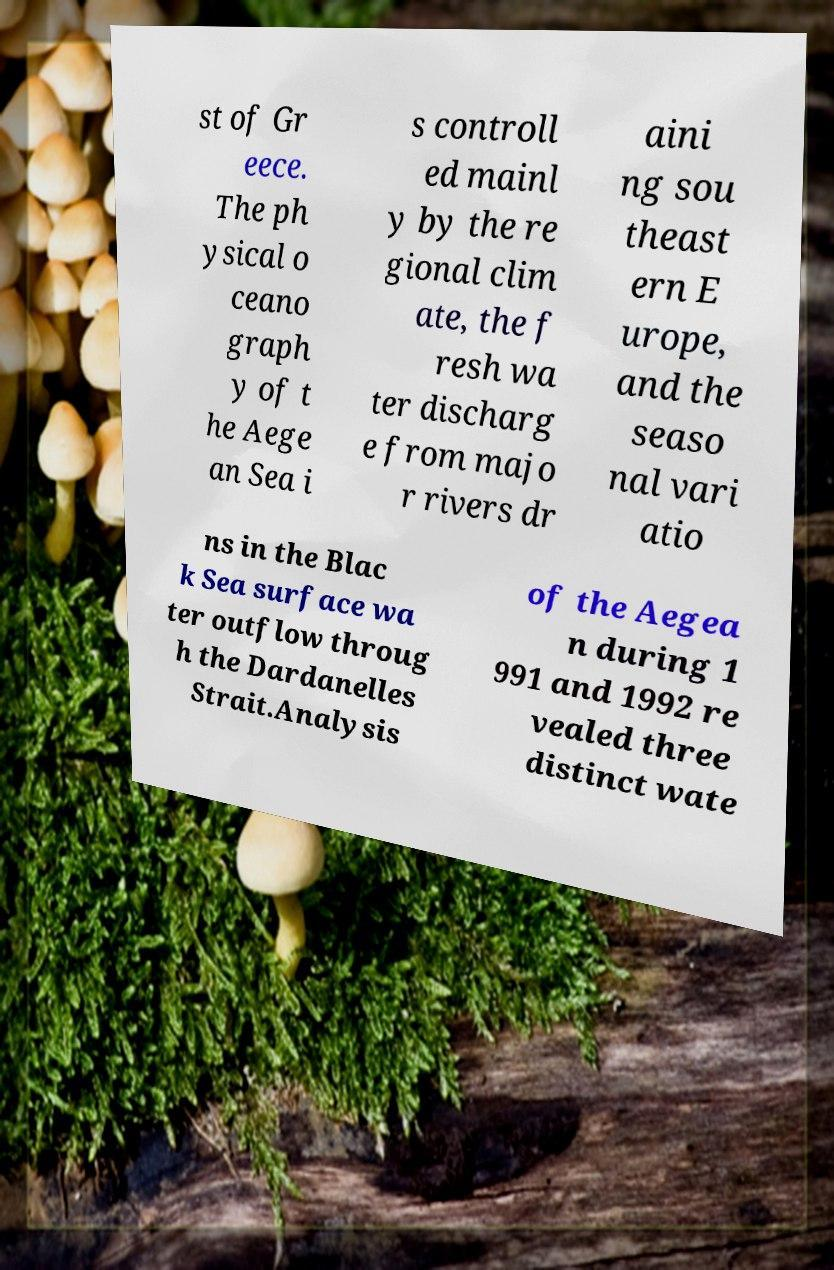Could you assist in decoding the text presented in this image and type it out clearly? st of Gr eece. The ph ysical o ceano graph y of t he Aege an Sea i s controll ed mainl y by the re gional clim ate, the f resh wa ter discharg e from majo r rivers dr aini ng sou theast ern E urope, and the seaso nal vari atio ns in the Blac k Sea surface wa ter outflow throug h the Dardanelles Strait.Analysis of the Aegea n during 1 991 and 1992 re vealed three distinct wate 